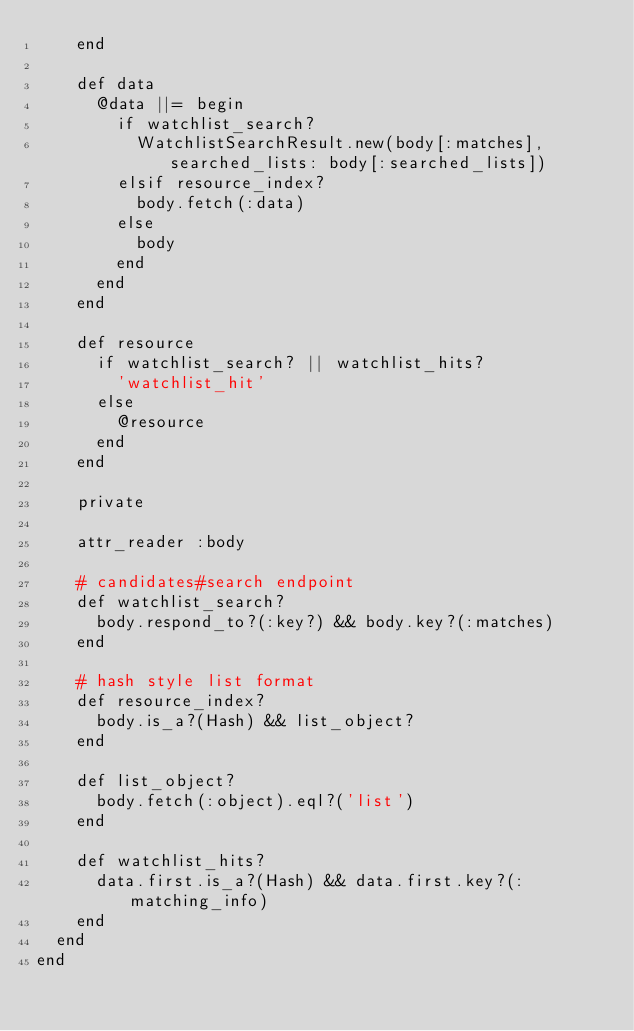<code> <loc_0><loc_0><loc_500><loc_500><_Ruby_>    end

    def data
      @data ||= begin
        if watchlist_search?
          WatchlistSearchResult.new(body[:matches], searched_lists: body[:searched_lists])
        elsif resource_index?
          body.fetch(:data)
        else
          body
        end
      end
    end

    def resource
      if watchlist_search? || watchlist_hits?
        'watchlist_hit'
      else
        @resource
      end
    end

    private

    attr_reader :body

    # candidates#search endpoint
    def watchlist_search?
      body.respond_to?(:key?) && body.key?(:matches)
    end

    # hash style list format
    def resource_index?
      body.is_a?(Hash) && list_object?
    end

    def list_object?
      body.fetch(:object).eql?('list')
    end

    def watchlist_hits?
      data.first.is_a?(Hash) && data.first.key?(:matching_info)
    end
  end
end
</code> 